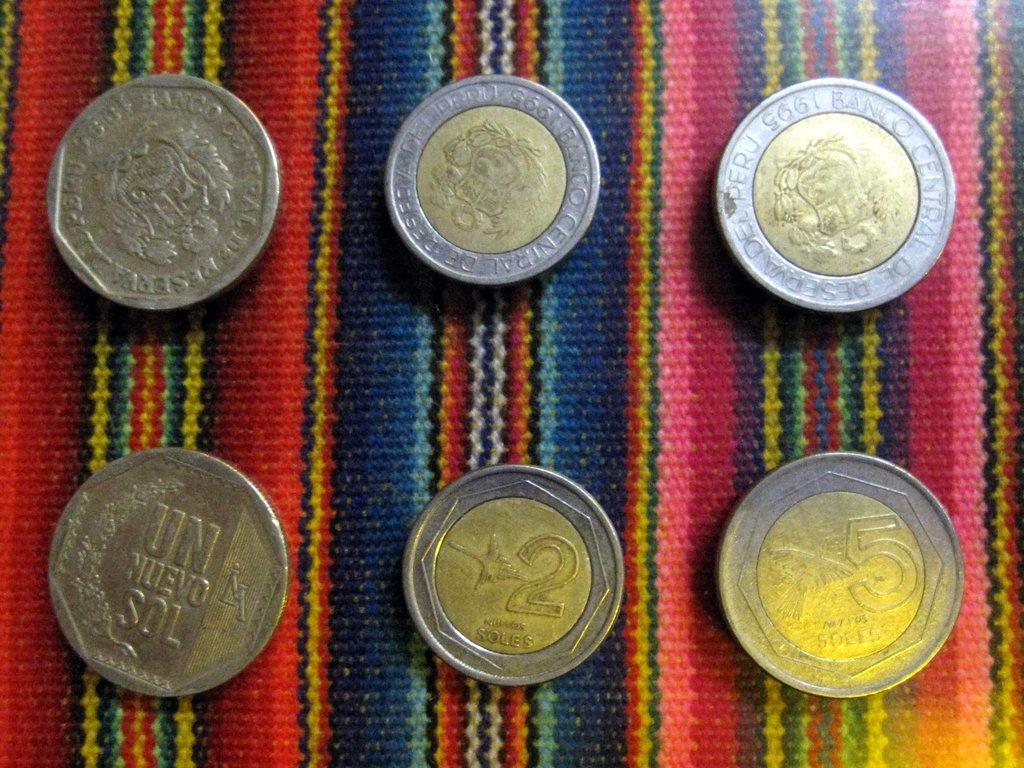How much is the middle coin worth?
Keep it short and to the point. 2. 